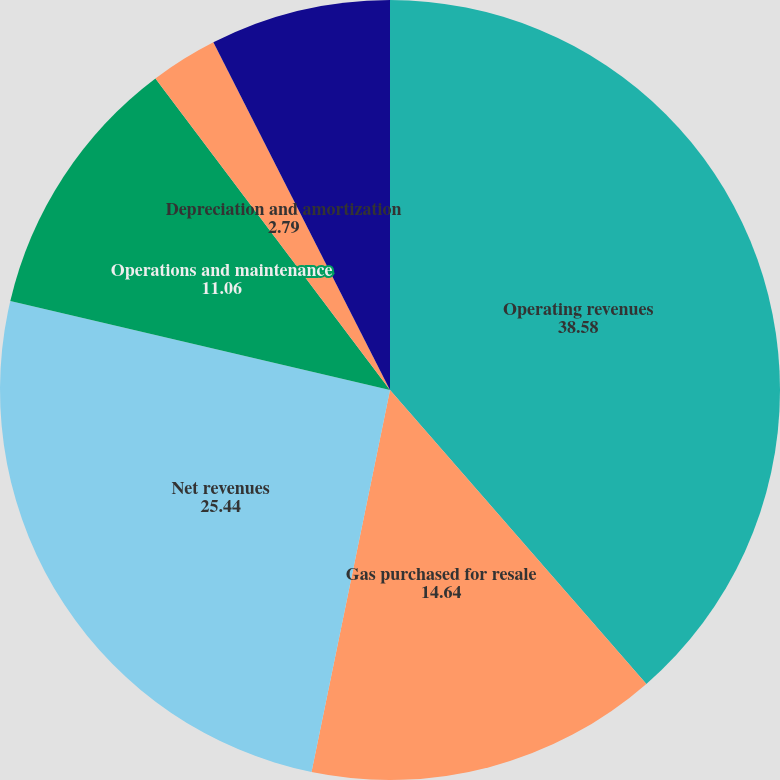Convert chart. <chart><loc_0><loc_0><loc_500><loc_500><pie_chart><fcel>Operating revenues<fcel>Gas purchased for resale<fcel>Net revenues<fcel>Operations and maintenance<fcel>Depreciation and amortization<fcel>Gas operating income<nl><fcel>38.58%<fcel>14.64%<fcel>25.44%<fcel>11.06%<fcel>2.79%<fcel>7.48%<nl></chart> 